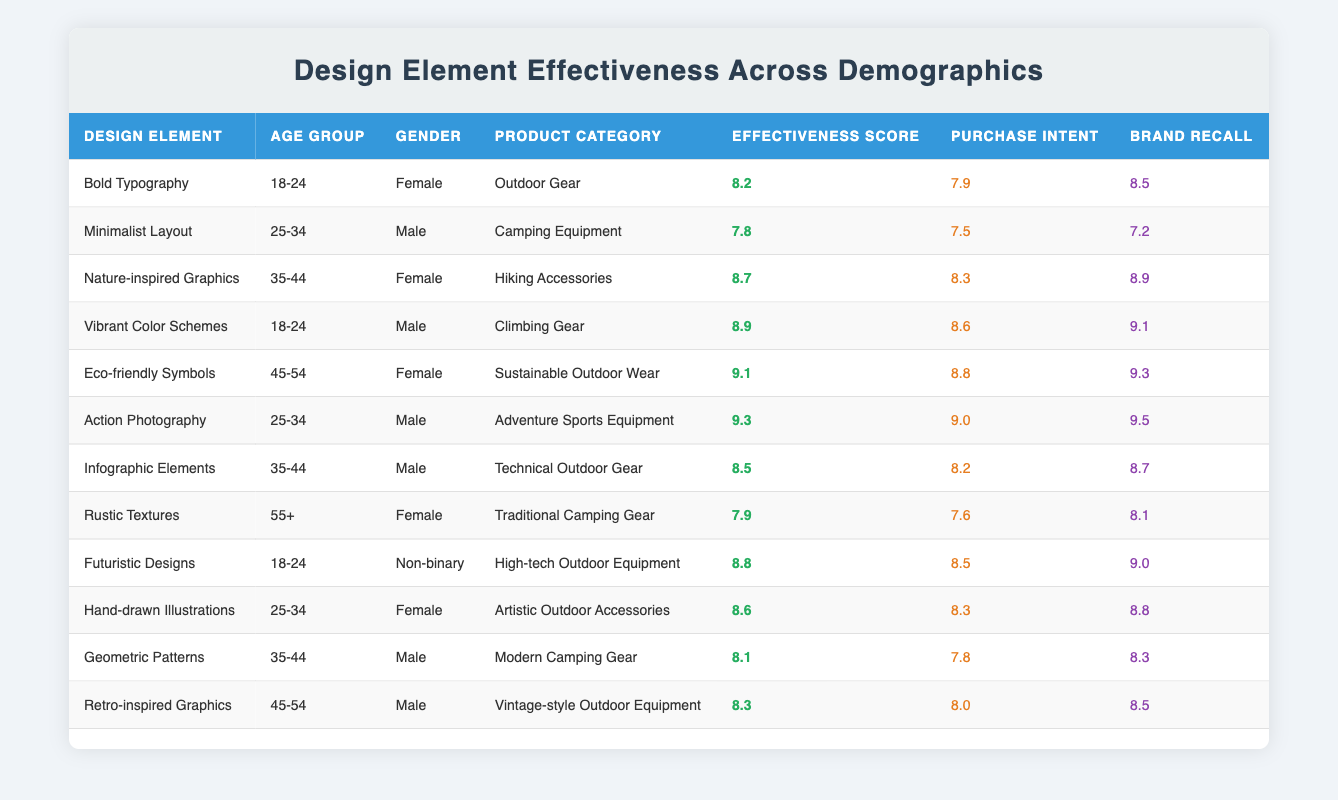What is the effectiveness score for "Action Photography"? You can find the row for "Action Photography" in the table. The effectiveness score for this design element is located in the fifth column. It reads 9.3.
Answer: 9.3 Which design element has the highest brand recall score for the age group 45-54? You look at the rows for the age group 45-54. The design elements for this age group are "Eco-friendly Symbols" and "Retro-inspired Graphics." Their brand recall scores are 9.3 and 8.5 respectively. Comparing these, 9.3 is the highest.
Answer: Eco-friendly Symbols What is the average effectiveness score for design elements targeted at the age group 18-24? The rows for the age group 18-24 include "Bold Typography," "Vibrant Color Schemes," and "Futuristic Designs." Their effectiveness scores are 8.2, 8.9, and 8.8 respectively. To find the average, sum these scores: 8.2 + 8.9 + 8.8 = 25.9, and then divide by 3, which gives 25.9 / 3 = 8.63.
Answer: 8.63 Is there a design element in the table that appeals equally to both male and female respondents? To check, we need to look at the gender columns for each design element and identify if any design element has been rated by both genders. In this case, "Nature-inspired Graphics" is rated by females, and "Action Photography" by males, indicating no design element appeals equally.
Answer: No What is the purchase intent for "Hand-drawn Illustrations," and how does it compare to "Nature-inspired Graphics"? Locate the row for "Hand-drawn Illustrations," which shows a purchase intent score of 8.3. For "Nature-inspired Graphics," it shows a purchase intent score of 8.3 as well. Since both scores are equal, I can determine that they have the same purchase intent.
Answer: 8.3, equal Which age group has the highest average brand recall score? Calculate the average brand recall for each age group. For 18-24: (8.5 + 9.1 + 9.0) / 3 = 8.87. For 25-34: (7.2 + 9.5 + 8.8) / 3 = 8.53. For 35-44: (8.9 + 8.7 + 8.3) / 3 = 8.66. For 45-54: (9.3 + 8.5) / 2 = 8.9. For 55+: 8.1. The highest average brand recall is for the age group 18-24 with 8.87.
Answer: 18-24 Are "Vibrant Color Schemes" and "Futuristic Designs" more effective than the average effectiveness score of 8.5? Check the effectiveness scores of both design elements. "Vibrant Color Schemes" is 8.9, and "Futuristic Designs" is 8.8. Both scores are higher than 8.5, confirming that they are indeed more effective.
Answer: Yes What is the difference in effectiveness scores between the "Eco-friendly Symbols" and "Rustic Textures"? "Eco-friendly Symbols" has an effectiveness score of 9.1 and "Rustic Textures" has an effectiveness score of 7.9. To find the difference, subtract 7.9 from 9.1, resulting in 9.1 - 7.9 = 1.2.
Answer: 1.2 